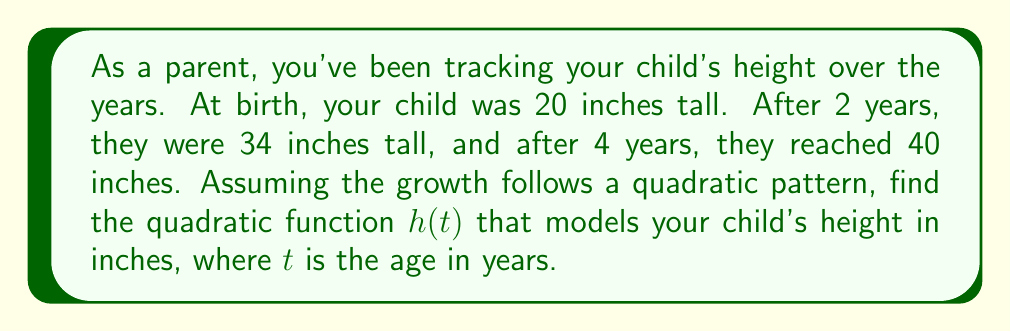Show me your answer to this math problem. Let's approach this step-by-step:

1) The general form of a quadratic function is $h(t) = at^2 + bt + c$, where $a$, $b$, and $c$ are constants we need to find.

2) We have three points:
   $(0, 20)$: At birth $(t=0)$, height is 20 inches
   $(2, 34)$: At 2 years, height is 34 inches
   $(4, 40)$: At 4 years, height is 40 inches

3) Substituting these points into the general form:
   $20 = a(0)^2 + b(0) + c$
   $34 = a(2)^2 + b(2) + c$
   $40 = a(4)^2 + b(4) + c$

4) From the first equation:
   $c = 20$

5) Substituting $c=20$ into the other two equations:
   $34 = 4a + 2b + 20$
   $40 = 16a + 4b + 20$

6) Simplifying:
   $14 = 4a + 2b$
   $20 = 16a + 4b$

7) Multiply the first equation by 2:
   $28 = 8a + 4b$
   $20 = 16a + 4b$

8) Subtract the second equation from the first:
   $8 = -8a$
   $a = -1$

9) Substitute $a=-1$ into $14 = 4a + 2b$:
   $14 = 4(-1) + 2b$
   $14 = -4 + 2b$
   $18 = 2b$
   $b = 9$

10) Therefore, the quadratic function is:
    $h(t) = -t^2 + 9t + 20$
Answer: $h(t) = -t^2 + 9t + 20$ 